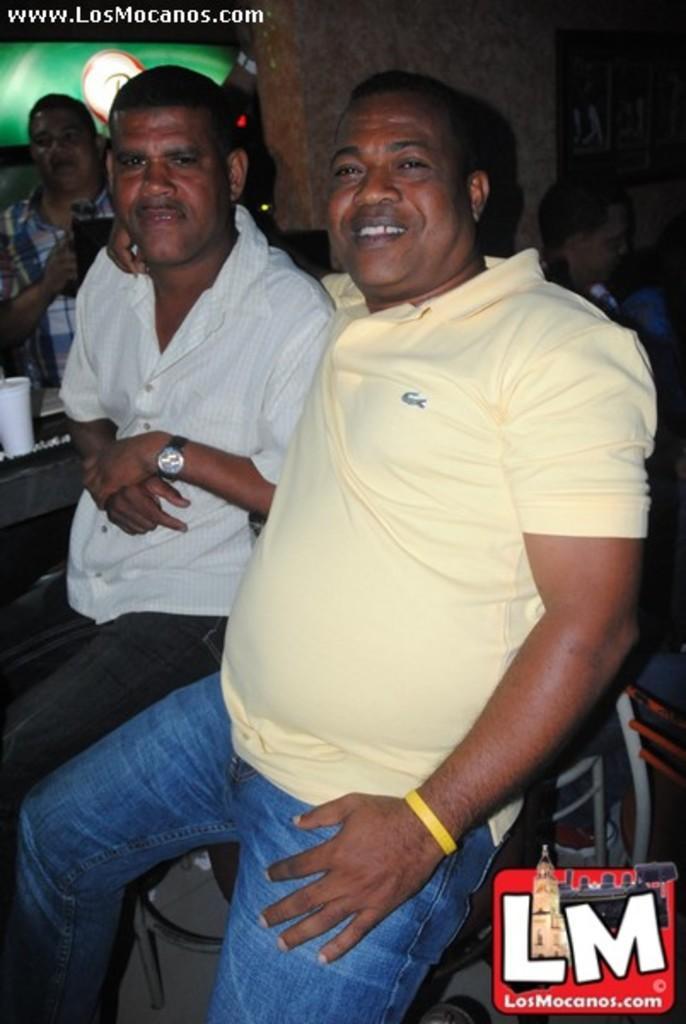Describe this image in one or two sentences. There are two members sitting on a stool here. One is wearing a yellow t shirt and a blue jean and another guy is wearing a watch and white shirt. The yellow t shirt guy is having a smile on his face. There in the background there is another man's standing there. we can observe a pillar here. 